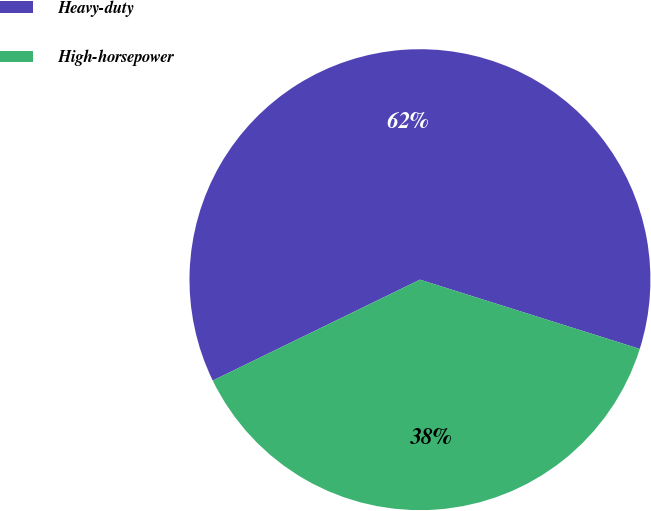<chart> <loc_0><loc_0><loc_500><loc_500><pie_chart><fcel>Heavy-duty<fcel>High-horsepower<nl><fcel>62.07%<fcel>37.93%<nl></chart> 